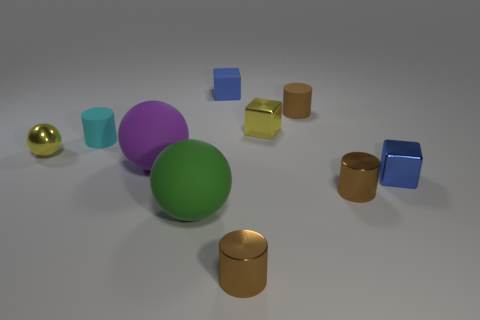Does the tiny block in front of the cyan matte object have the same color as the tiny matte cube?
Make the answer very short. Yes. What is the material of the tiny cube that is in front of the blue rubber object and behind the small cyan matte cylinder?
Provide a succinct answer. Metal. There is a small yellow metal sphere left of the green object; is there a sphere on the left side of it?
Provide a short and direct response. No. Are the cyan cylinder and the yellow cube made of the same material?
Offer a terse response. No. There is a metallic thing that is both behind the blue metallic block and right of the large green rubber object; what shape is it?
Offer a very short reply. Cube. What is the size of the cylinder in front of the small brown cylinder to the right of the brown rubber object?
Provide a short and direct response. Small. What number of yellow things have the same shape as the large purple thing?
Provide a succinct answer. 1. Do the small matte cube and the small shiny sphere have the same color?
Your answer should be very brief. No. Is there any other thing that has the same shape as the cyan matte thing?
Your answer should be compact. Yes. Is there a small matte cylinder that has the same color as the rubber block?
Make the answer very short. No. 